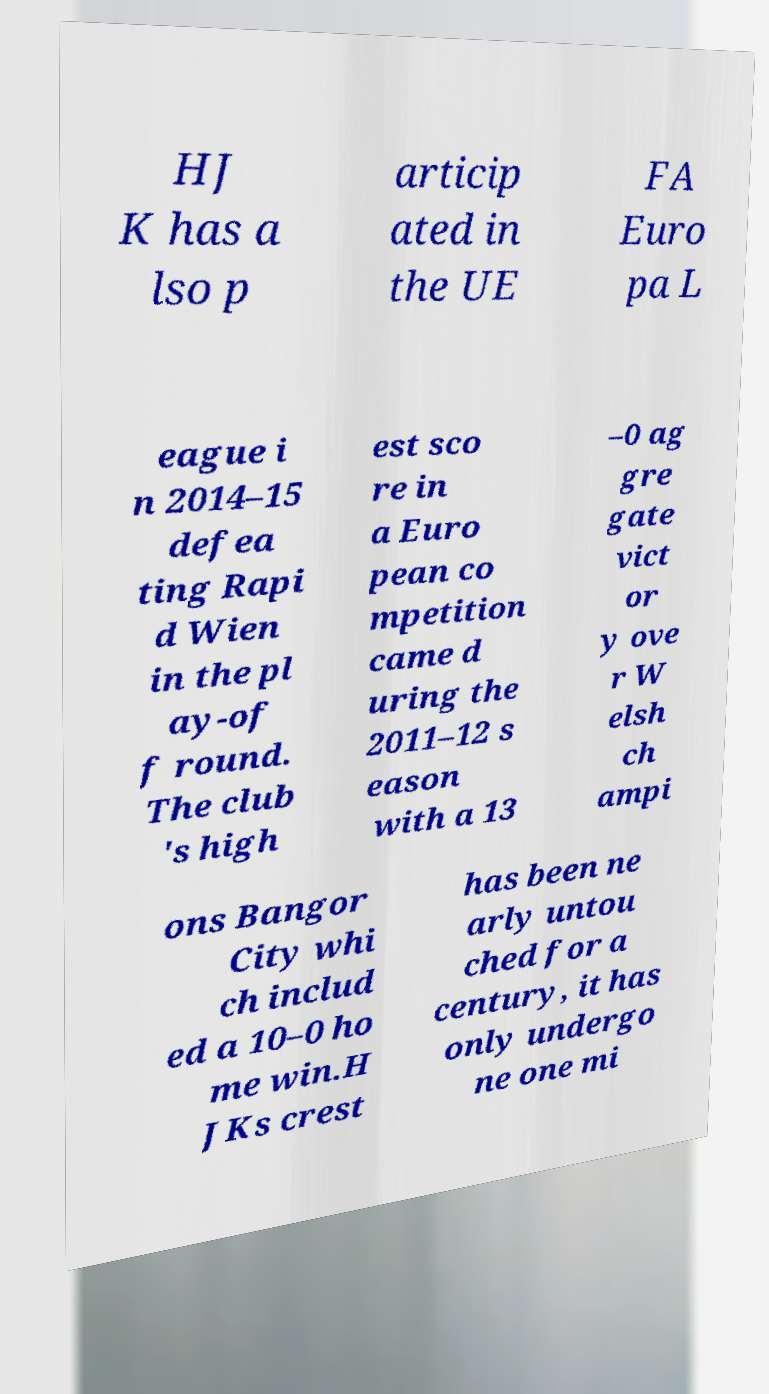Can you accurately transcribe the text from the provided image for me? HJ K has a lso p articip ated in the UE FA Euro pa L eague i n 2014–15 defea ting Rapi d Wien in the pl ay-of f round. The club 's high est sco re in a Euro pean co mpetition came d uring the 2011–12 s eason with a 13 –0 ag gre gate vict or y ove r W elsh ch ampi ons Bangor City whi ch includ ed a 10–0 ho me win.H JKs crest has been ne arly untou ched for a century, it has only undergo ne one mi 